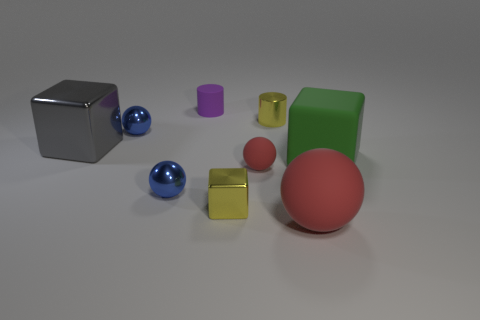Add 1 tiny green metal balls. How many objects exist? 10 Subtract all cylinders. How many objects are left? 7 Add 9 tiny purple cylinders. How many tiny purple cylinders exist? 10 Subtract 0 red blocks. How many objects are left? 9 Subtract all small purple metallic cylinders. Subtract all small rubber cylinders. How many objects are left? 8 Add 3 blue spheres. How many blue spheres are left? 5 